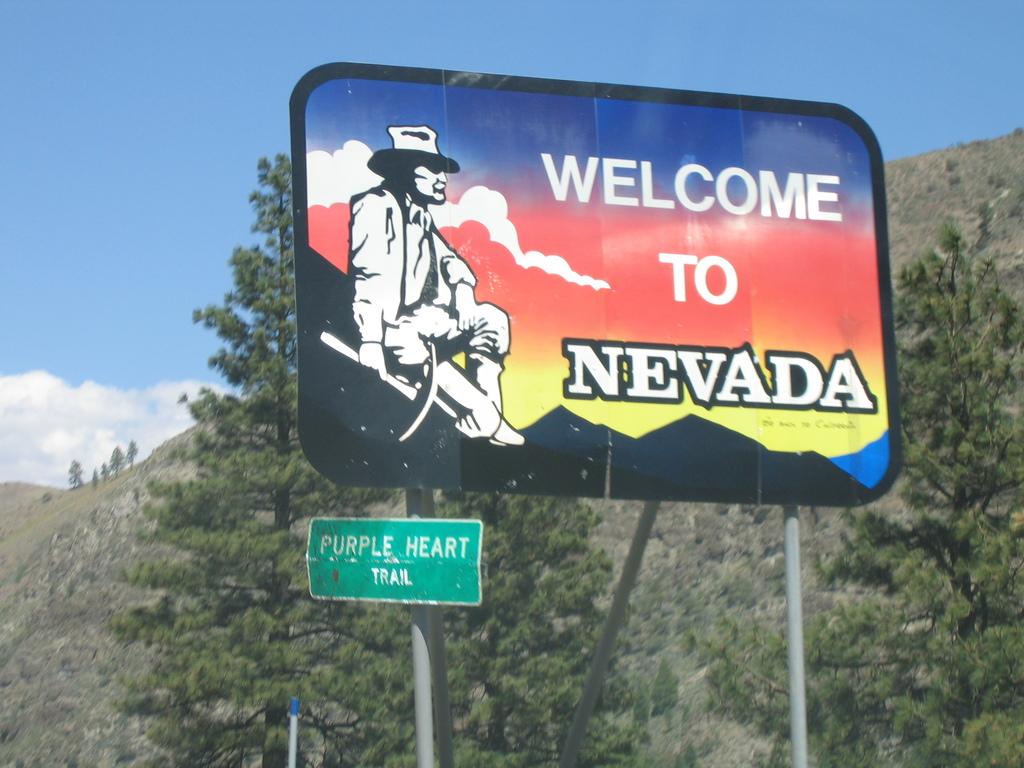Where is this billboard?
Offer a terse response. Nevada. 